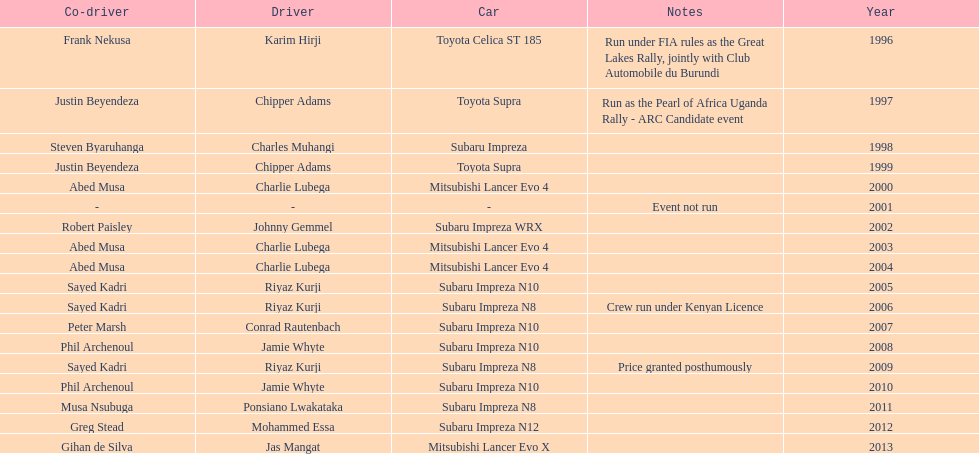Do chipper adams and justin beyendeza have more than 3 wins? No. 